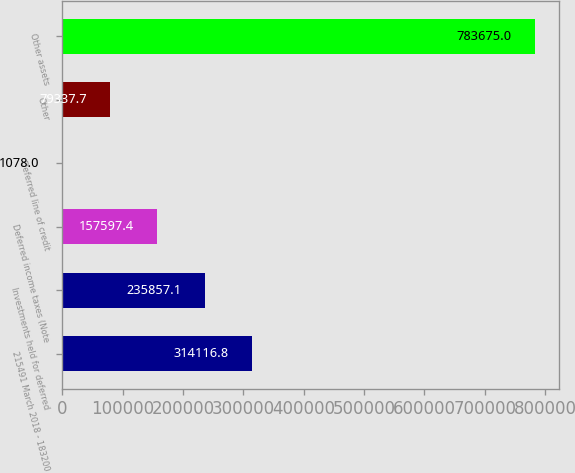<chart> <loc_0><loc_0><loc_500><loc_500><bar_chart><fcel>215491 March 2018 - 183200<fcel>Investments held for deferred<fcel>Deferred income taxes (Note<fcel>Deferred line of credit<fcel>Other<fcel>Other assets<nl><fcel>314117<fcel>235857<fcel>157597<fcel>1078<fcel>79337.7<fcel>783675<nl></chart> 